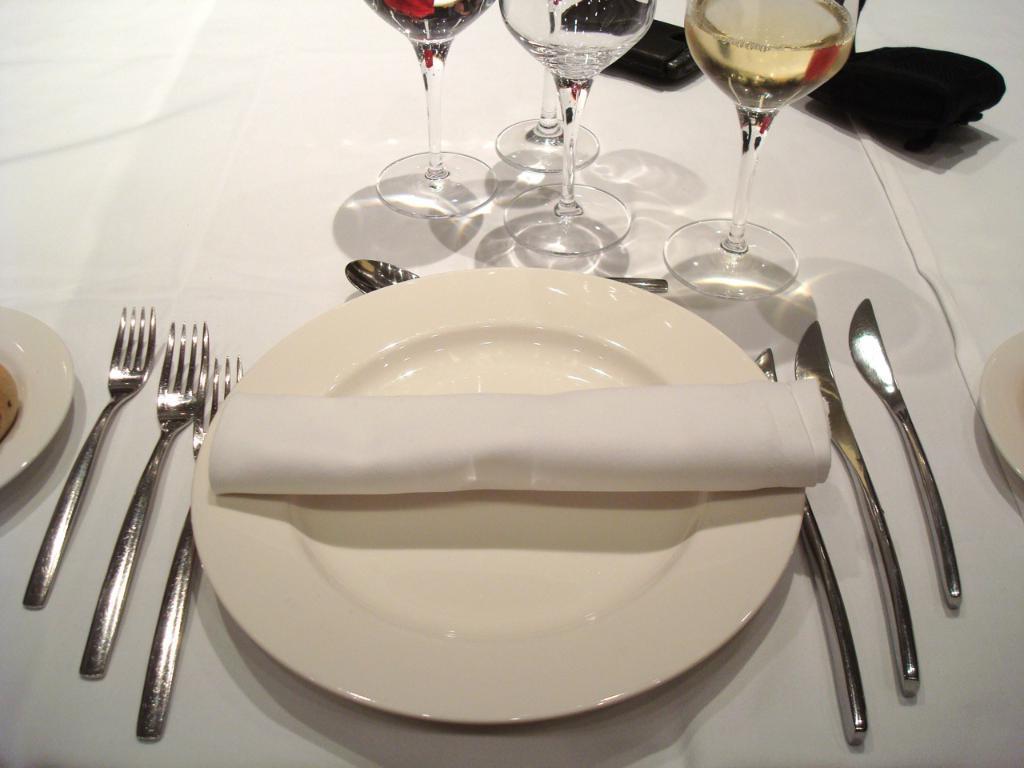Describe this image in one or two sentences. In this image we can see plates, glasses, forks, spoon and some other objects on the table. 